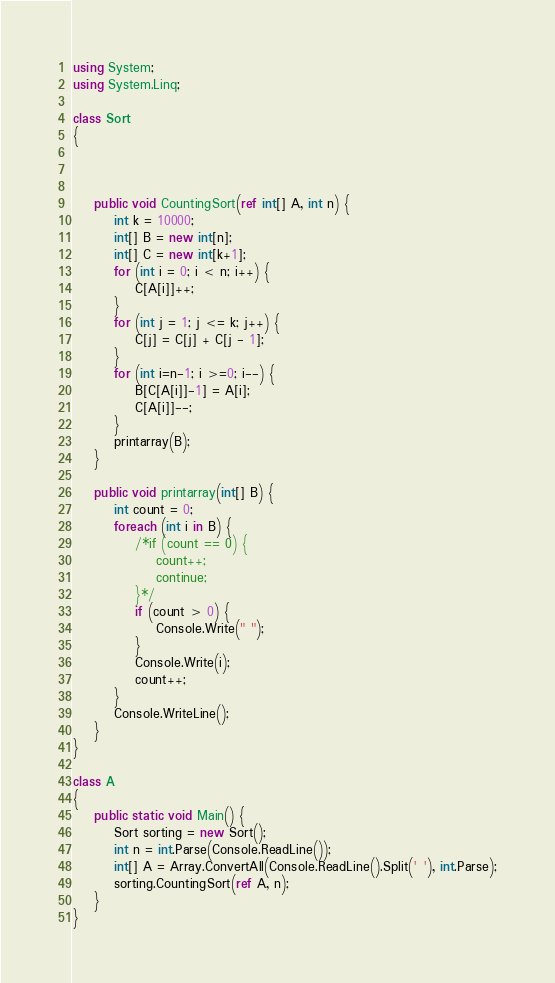<code> <loc_0><loc_0><loc_500><loc_500><_C#_>using System;
using System.Linq;

class Sort
{



    public void CountingSort(ref int[] A, int n) {
        int k = 10000;
        int[] B = new int[n];
        int[] C = new int[k+1];
        for (int i = 0; i < n; i++) {
            C[A[i]]++;
        }
        for (int j = 1; j <= k; j++) {
            C[j] = C[j] + C[j - 1];
        }
        for (int i=n-1; i >=0; i--) {
            B[C[A[i]]-1] = A[i];
            C[A[i]]--;
        }
        printarray(B);
    }

    public void printarray(int[] B) {
        int count = 0;
        foreach (int i in B) {
            /*if (count == 0) {
                count++;
                continue;
            }*/
            if (count > 0) {
                Console.Write(" ");
            }
            Console.Write(i);
            count++;
        }
        Console.WriteLine();
    }
}

class A
{
    public static void Main() {
        Sort sorting = new Sort();
        int n = int.Parse(Console.ReadLine());
        int[] A = Array.ConvertAll(Console.ReadLine().Split(' '), int.Parse);
        sorting.CountingSort(ref A, n);
    }
}

</code> 